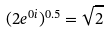Convert formula to latex. <formula><loc_0><loc_0><loc_500><loc_500>( 2 e ^ { 0 i } ) ^ { 0 . 5 } = \sqrt { 2 }</formula> 